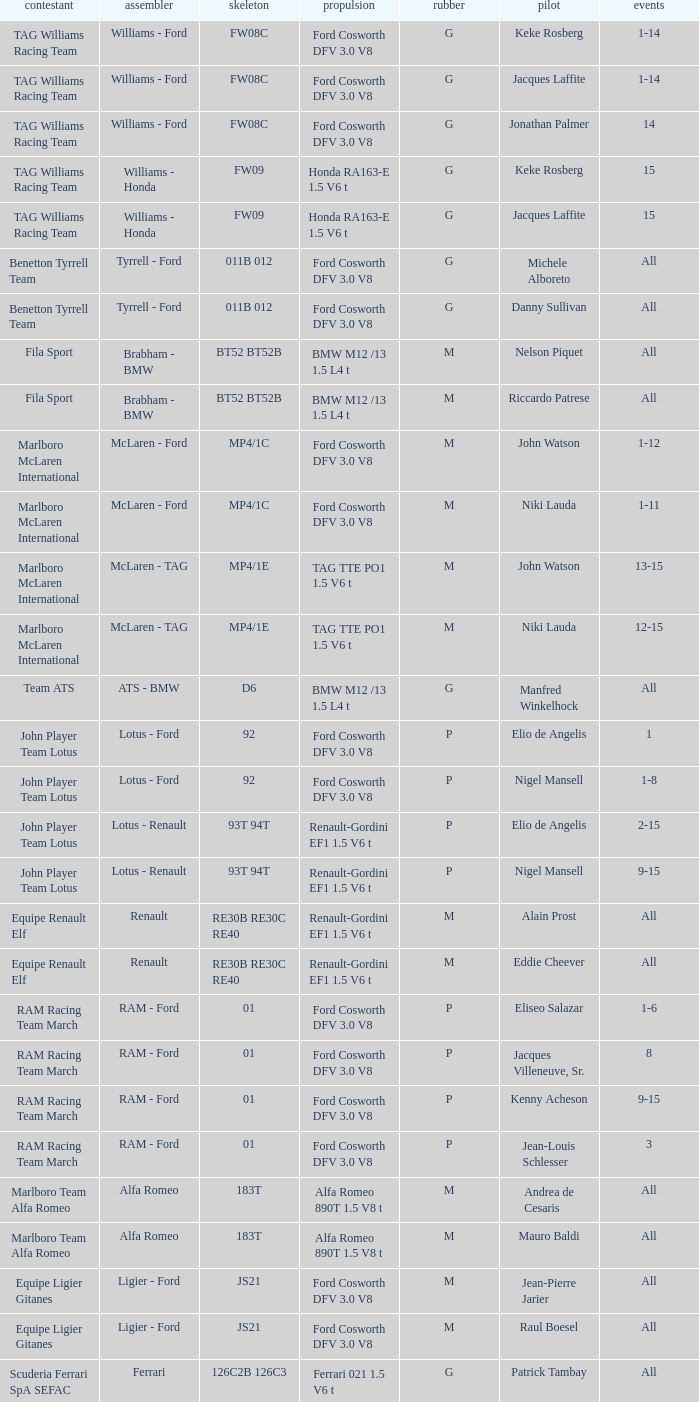Who is driver of the d6 chassis? Manfred Winkelhock. 